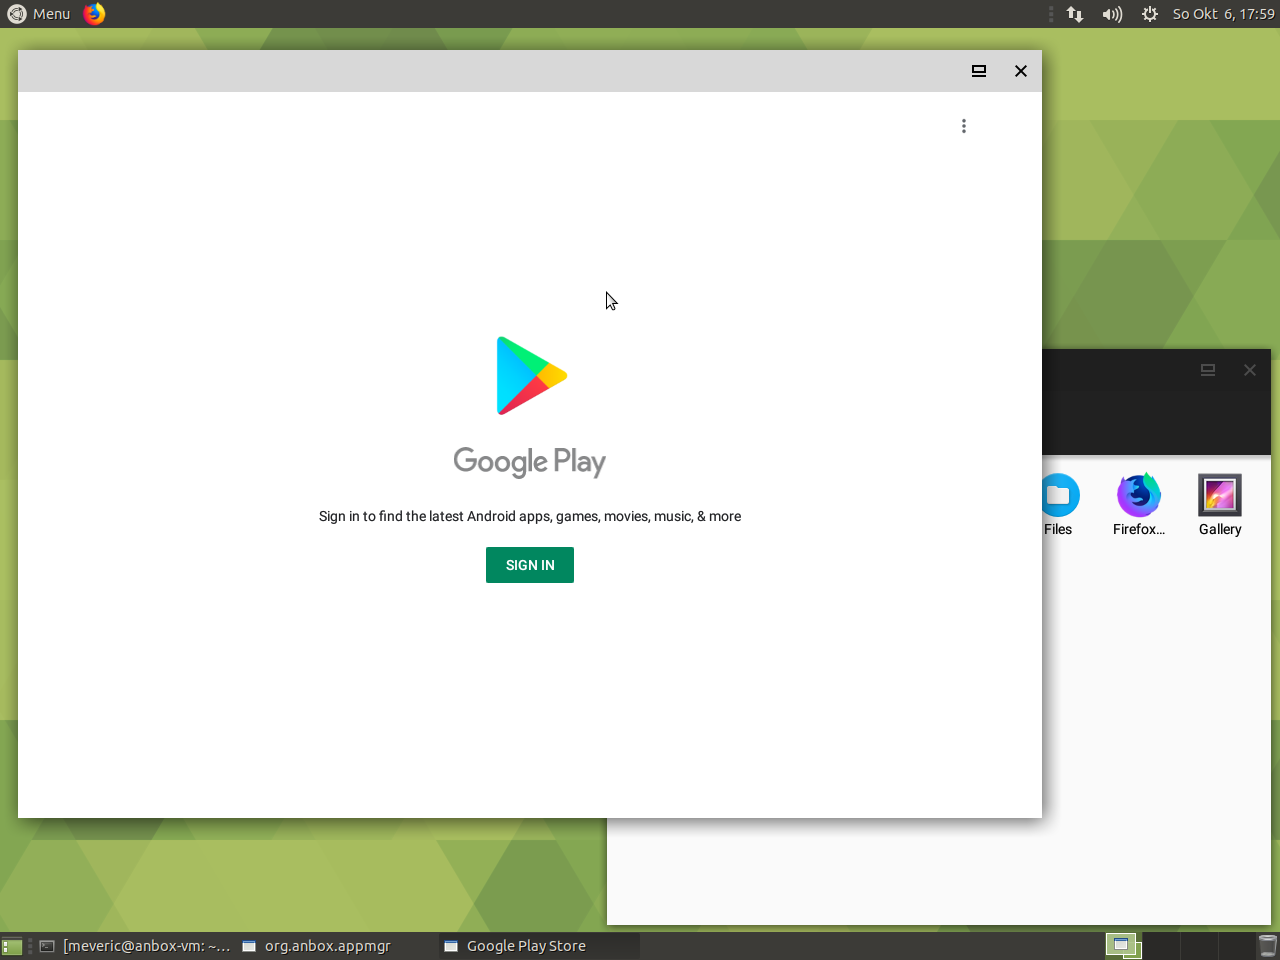What might the battery icon indicate about the current state of the device's power? The battery icon at the top right corner of the screen generally indicates the current charging state and the remaining battery life of the device. However, the specific details such as the percentage of charge left or whether the device is plugged in and charging cannot be determined from this image as there is no visible indicator within the battery icon or adjacent to it. The mere presence of the battery icon does suggest that the device is either a laptop or a portable device that relies on battery power. 